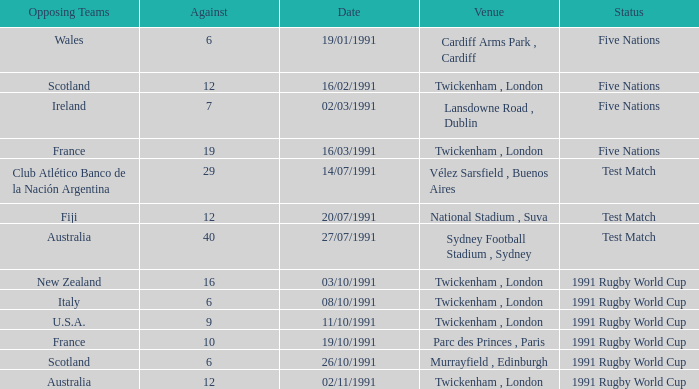Who was the opposing team against australia on 27/07/1991? 40.0. 